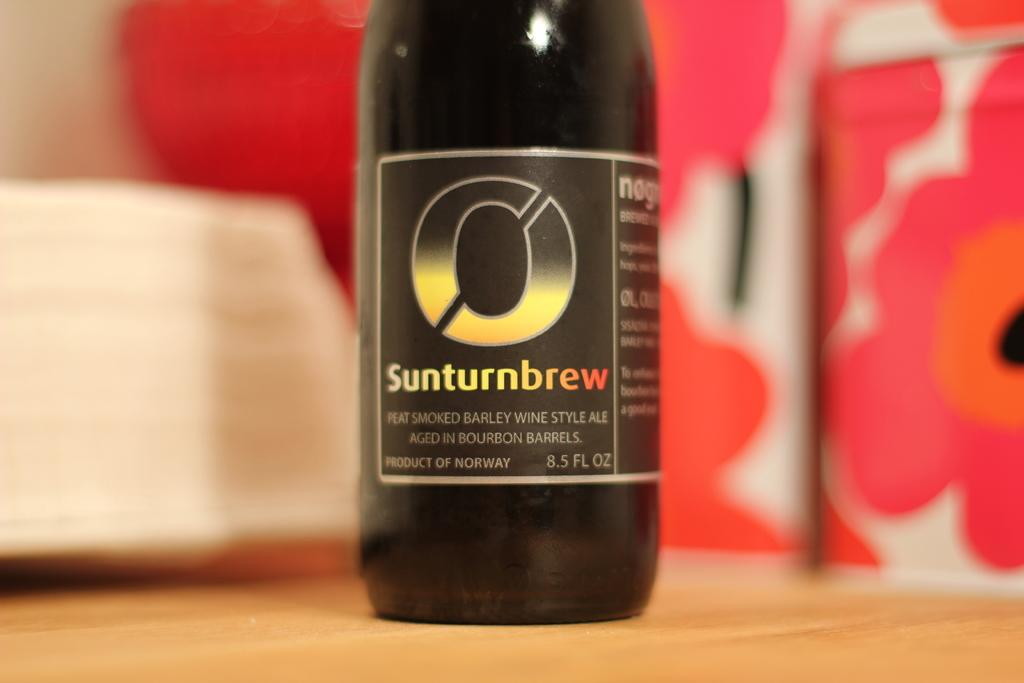How many fl oz are in this bottle?
Provide a short and direct response. 8.5. 